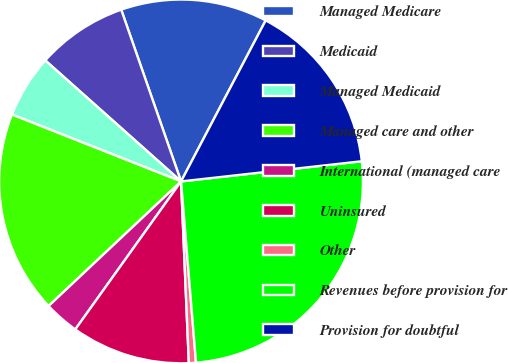Convert chart. <chart><loc_0><loc_0><loc_500><loc_500><pie_chart><fcel>Managed Medicare<fcel>Medicaid<fcel>Managed Medicaid<fcel>Managed care and other<fcel>International (managed care<fcel>Uninsured<fcel>Other<fcel>Revenues before provision for<fcel>Provision for doubtful<nl><fcel>13.04%<fcel>8.08%<fcel>5.59%<fcel>18.01%<fcel>3.11%<fcel>10.56%<fcel>0.63%<fcel>25.46%<fcel>15.53%<nl></chart> 